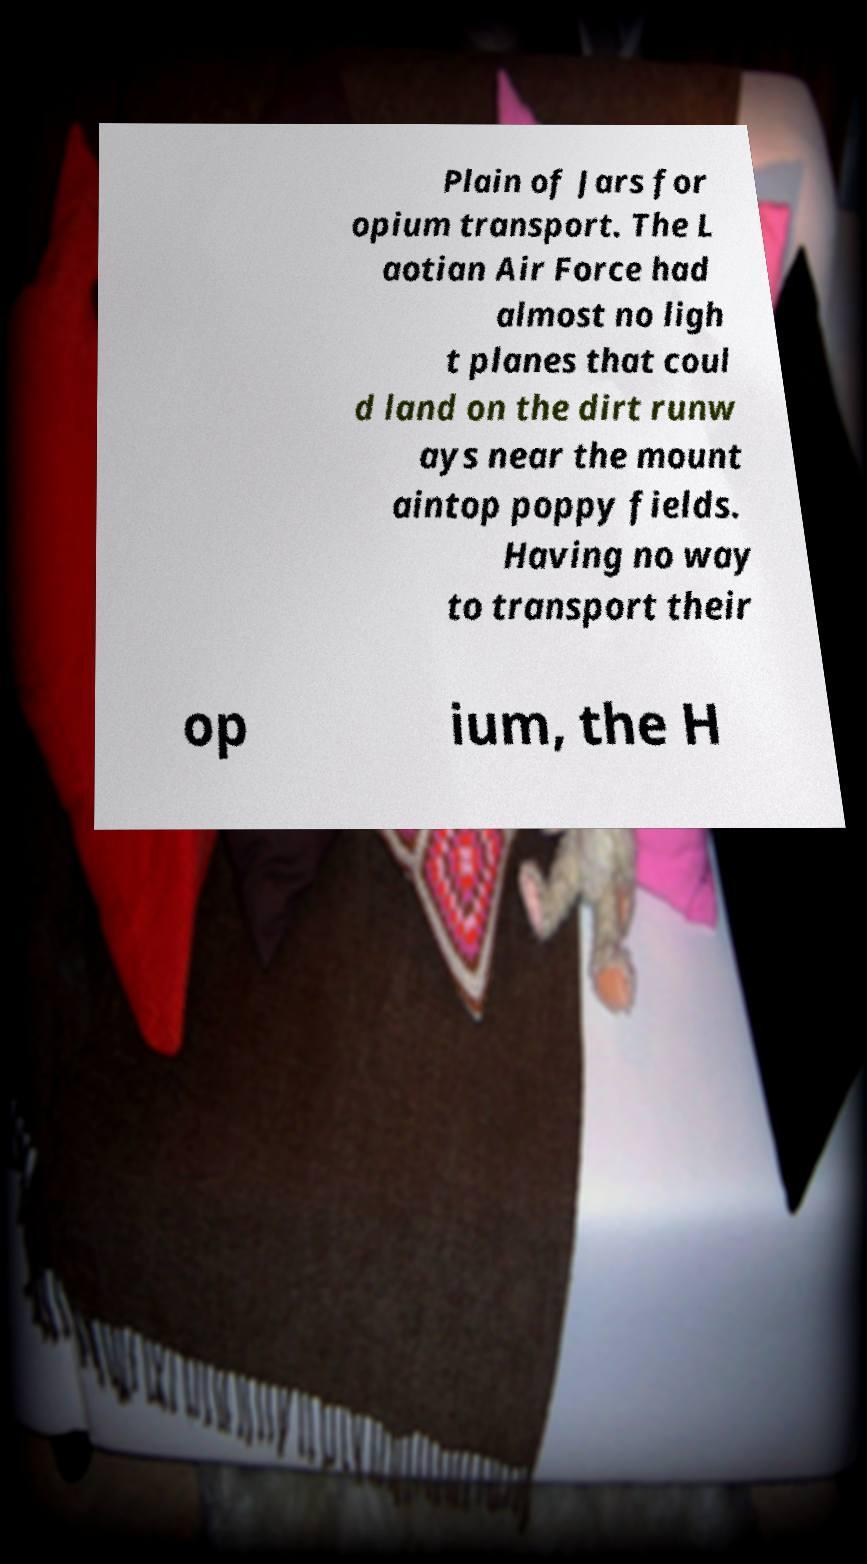What messages or text are displayed in this image? I need them in a readable, typed format. Plain of Jars for opium transport. The L aotian Air Force had almost no ligh t planes that coul d land on the dirt runw ays near the mount aintop poppy fields. Having no way to transport their op ium, the H 